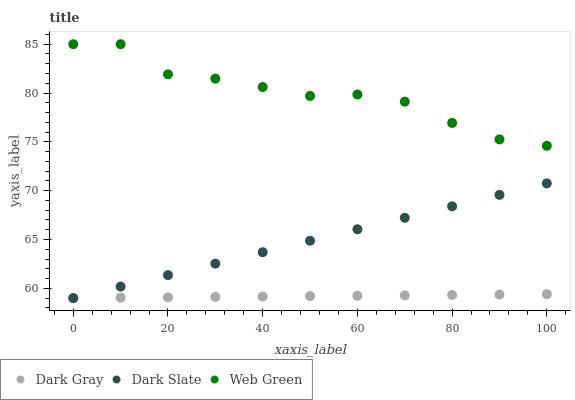Does Dark Gray have the minimum area under the curve?
Answer yes or no. Yes. Does Web Green have the maximum area under the curve?
Answer yes or no. Yes. Does Dark Slate have the minimum area under the curve?
Answer yes or no. No. Does Dark Slate have the maximum area under the curve?
Answer yes or no. No. Is Dark Gray the smoothest?
Answer yes or no. Yes. Is Web Green the roughest?
Answer yes or no. Yes. Is Dark Slate the smoothest?
Answer yes or no. No. Is Dark Slate the roughest?
Answer yes or no. No. Does Dark Gray have the lowest value?
Answer yes or no. Yes. Does Web Green have the lowest value?
Answer yes or no. No. Does Web Green have the highest value?
Answer yes or no. Yes. Does Dark Slate have the highest value?
Answer yes or no. No. Is Dark Gray less than Web Green?
Answer yes or no. Yes. Is Web Green greater than Dark Gray?
Answer yes or no. Yes. Does Dark Gray intersect Dark Slate?
Answer yes or no. Yes. Is Dark Gray less than Dark Slate?
Answer yes or no. No. Is Dark Gray greater than Dark Slate?
Answer yes or no. No. Does Dark Gray intersect Web Green?
Answer yes or no. No. 